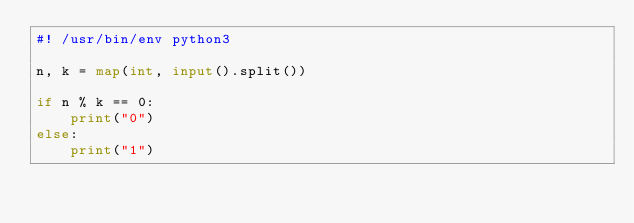Convert code to text. <code><loc_0><loc_0><loc_500><loc_500><_Python_>#! /usr/bin/env python3

n, k = map(int, input().split())

if n % k == 0:
    print("0")
else:
    print("1")
</code> 